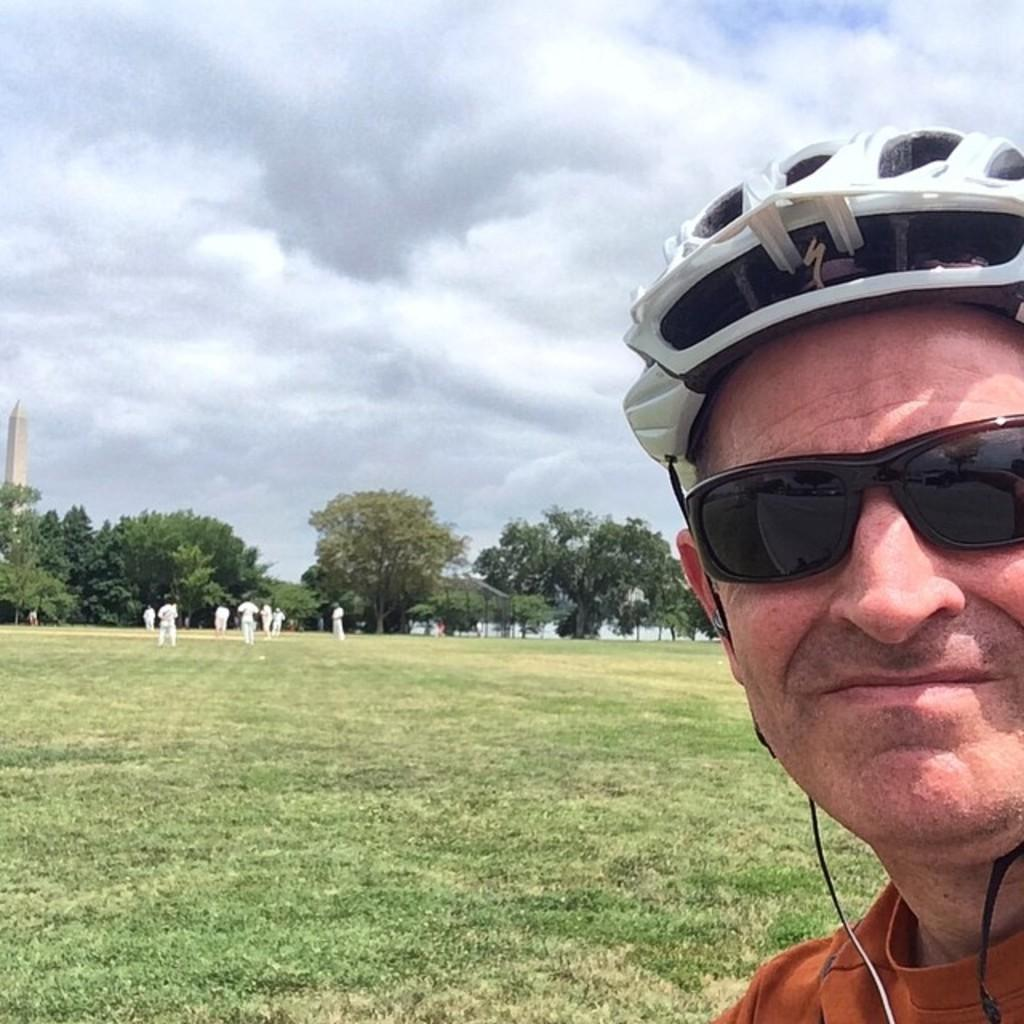What is the man on the right side of the image wearing? The man is wearing goggles and a helmet. What can be seen beneath the man's feet in the image? The ground is visible in the image. What is visible above the man's head in the image? The sky is visible in the image. What can be seen in the background of the image? There are people and trees in the background of the image. What structure is located on the left side of the image? There is a building on the left side of the image. What type of oven can be seen in the image? There is no oven present in the image. What direction is the man pointing in the image? The image does not show the man pointing in any direction. 